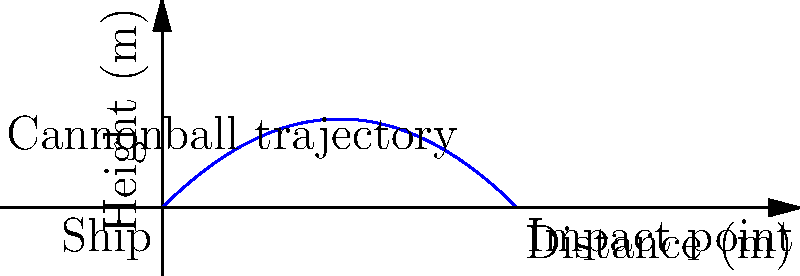In your latest historical fiction novel set in the Caribbean, you're describing a naval battle. A cannonball is fired from a ship's deck at sea level with an initial velocity of 50 m/s at an angle of 45° above the horizontal. Assuming no air resistance, what is the maximum height reached by the cannonball? Express your answer in meters, rounded to the nearest whole number. To find the maximum height of the cannonball, we'll follow these steps:

1) The vertical component of the initial velocity is:
   $v_{0y} = v_0 \sin \theta = 50 \cdot \sin 45° = 50 \cdot \frac{\sqrt{2}}{2} \approx 35.36$ m/s

2) The time to reach the maximum height is when the vertical velocity becomes zero:
   $v_y = v_{0y} - gt = 0$
   $t = \frac{v_{0y}}{g} = \frac{35.36}{9.8} \approx 3.61$ seconds

3) The maximum height is reached at half the total flight time. We can use the equation:
   $y = v_{0y}t - \frac{1}{2}gt^2$

4) Substituting the time we found:
   $y_{max} = 35.36 \cdot 3.61 - \frac{1}{2} \cdot 9.8 \cdot 3.61^2$
   $y_{max} = 127.65 - 63.82 = 63.83$ meters

5) Rounding to the nearest whole number:
   $y_{max} \approx 64$ meters

This maximum height would occur at the midpoint of the cannonball's trajectory, as shown in the diagram.
Answer: 64 meters 